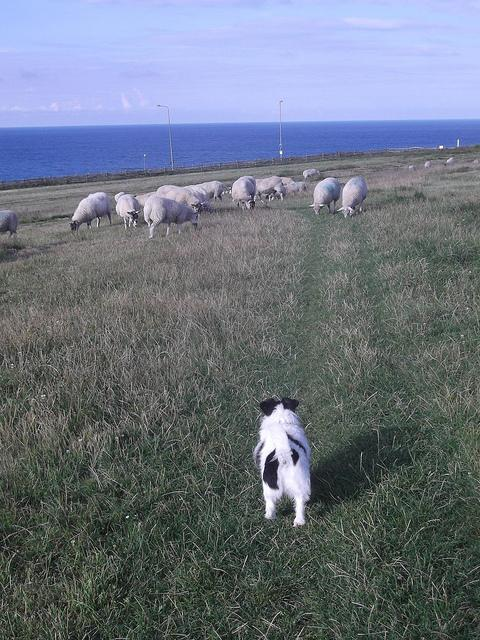What animal is facing the herd? dog 